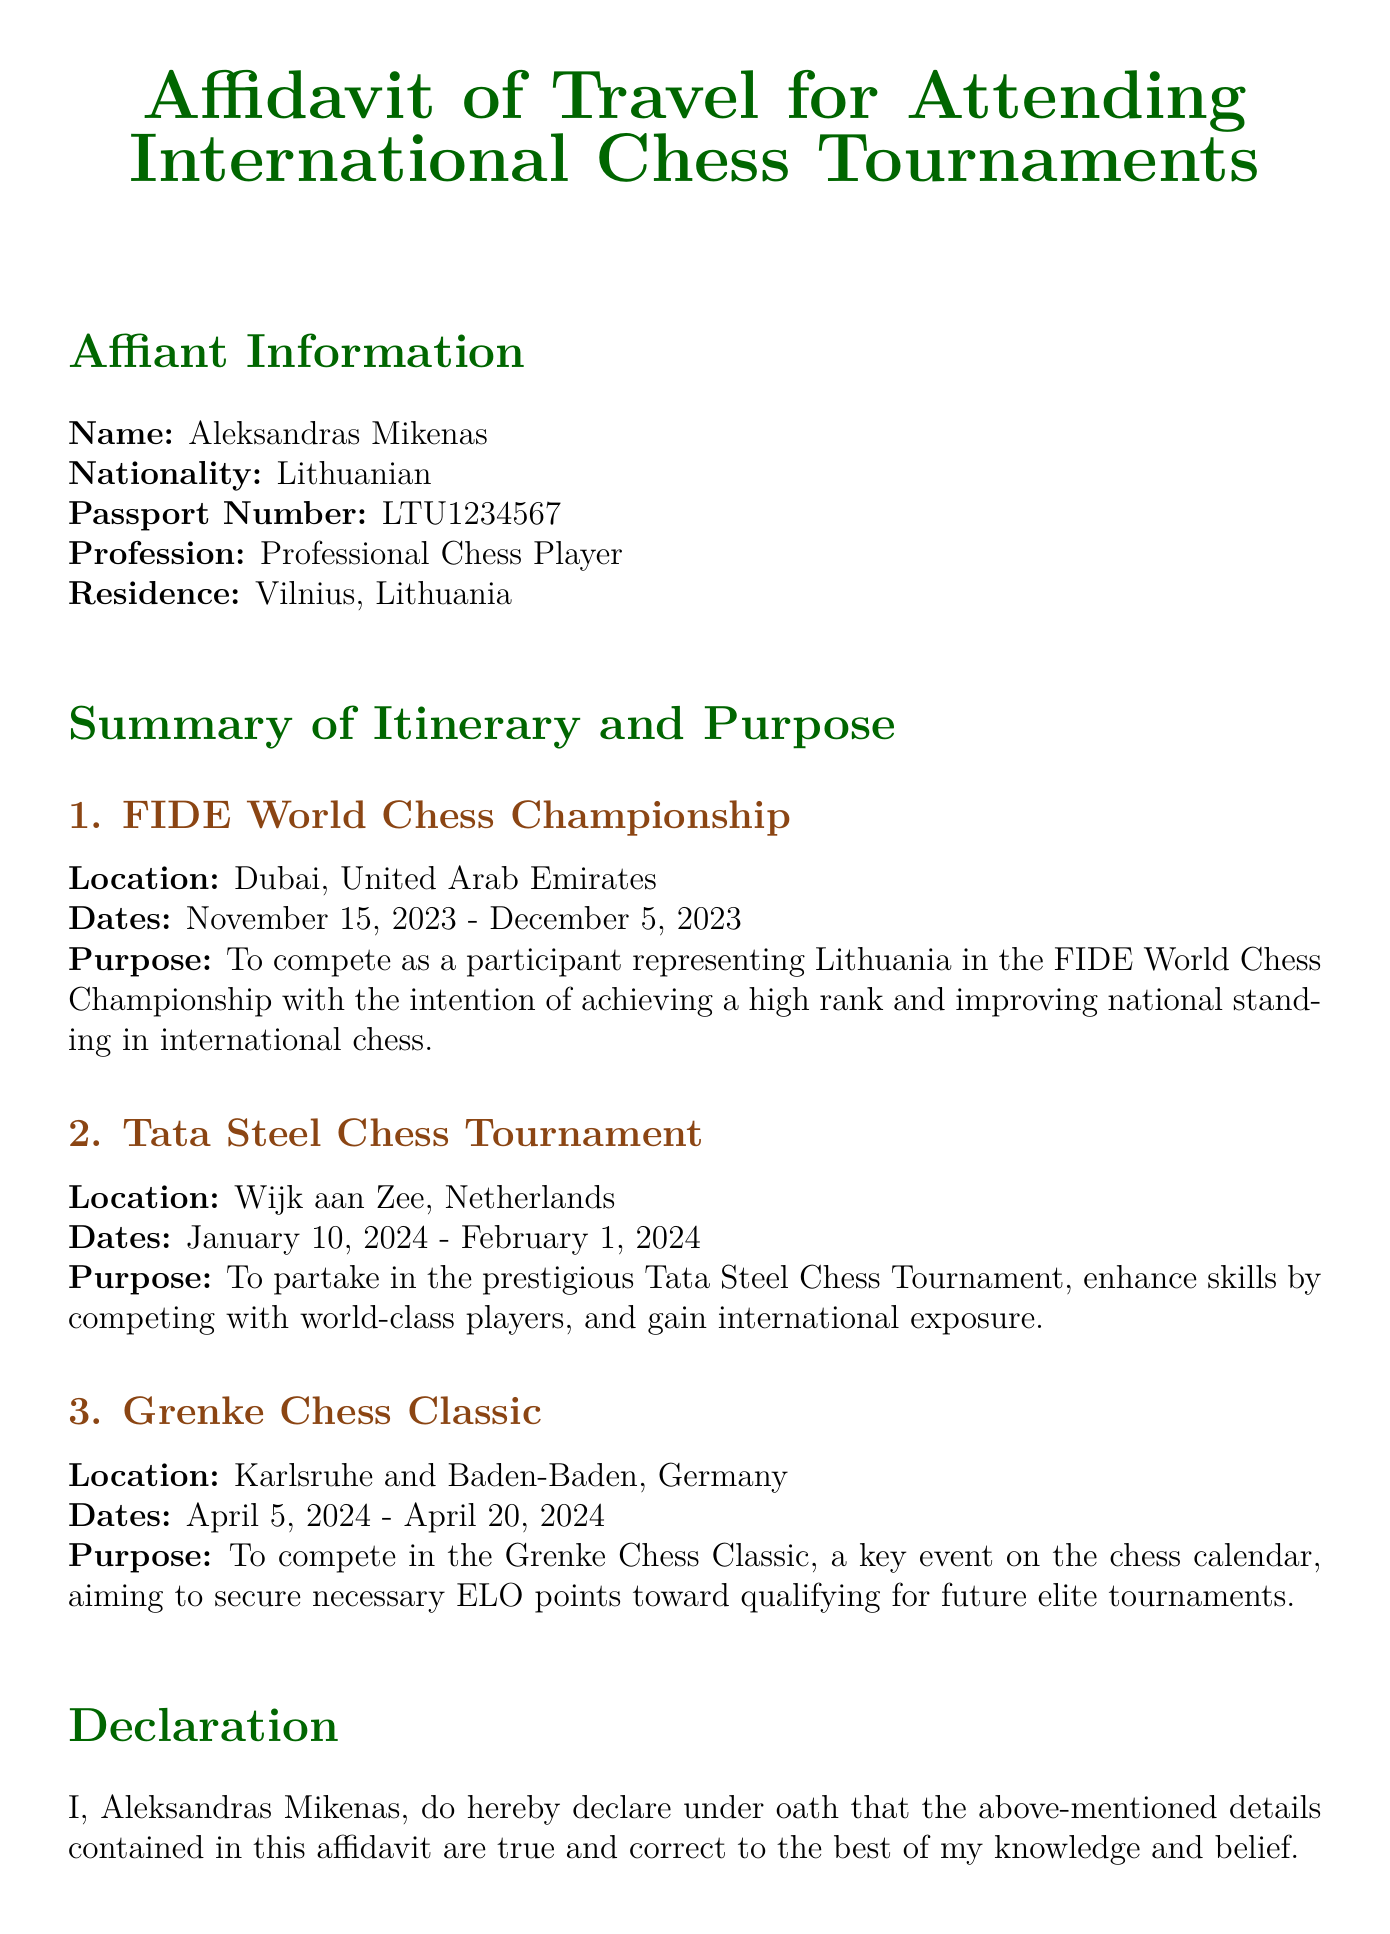What is the name of the affiant? The name of the affiant is stated in the document under Affiant Information.
Answer: Aleksandras Mikenas What is the nationality of the affiant? The nationality is mentioned in the Affiant Information section.
Answer: Lithuanian What is the passport number of the affiant? The passport number is provided in the Affiant Information section.
Answer: LTU1234567 When does the FIDE World Chess Championship take place? The dates for the FIDE World Chess Championship are listed in the Summary of Itinerary section.
Answer: November 15, 2023 - December 5, 2023 What is the main purpose of traveling for the FIDE World Chess Championship? The purpose is described in the Summary of Itinerary section.
Answer: To compete as a participant representing Lithuania How many chess tournaments are mentioned in the document? By counting the distinct tournament sections in the Summary of Itinerary, we can find the number.
Answer: Three What is the location of the Grenke Chess Classic? The location is specified in the Summary of Itinerary section.
Answer: Karlsruhe and Baden-Baden, Germany What date was the affidavit signed? The date of signature is indicated toward the end of the document.
Answer: October 4, 2023 Who notarized the affidavit? The notary's name is recorded in the Notarization section of the document.
Answer: Daiva Jurate 